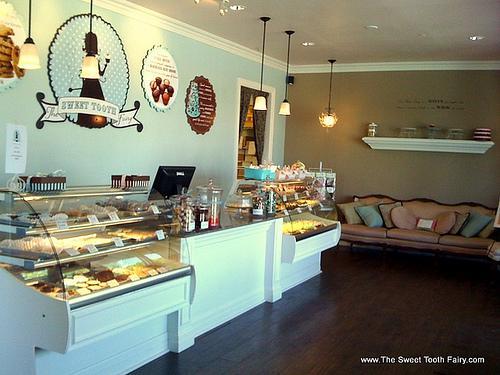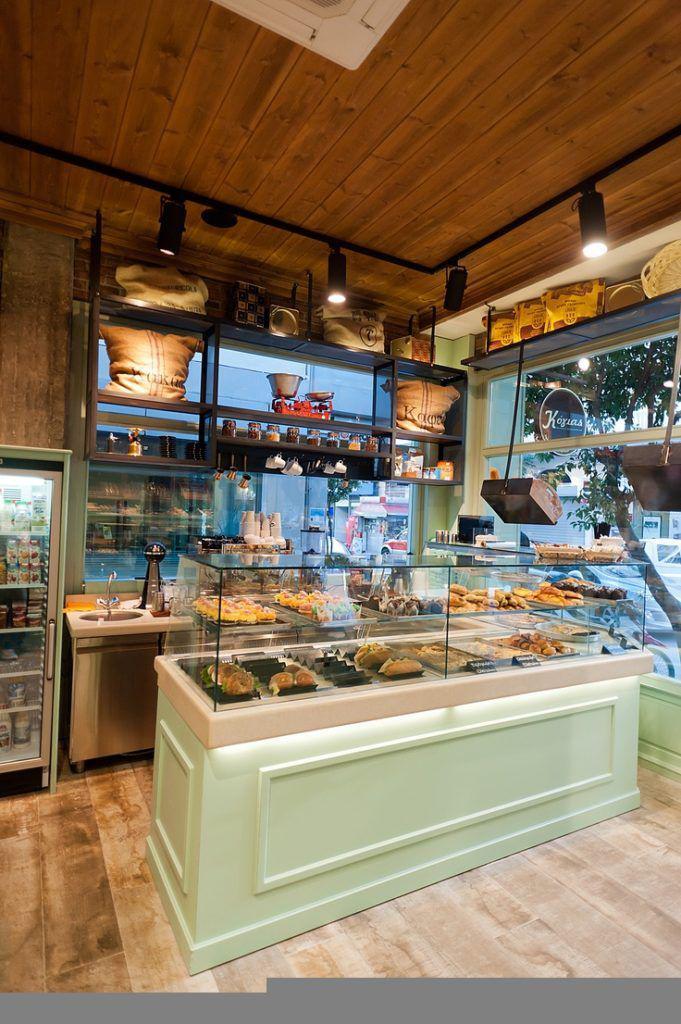The first image is the image on the left, the second image is the image on the right. For the images shown, is this caption "A bakery in one image has an indoor seating area for customers." true? Answer yes or no. Yes. 